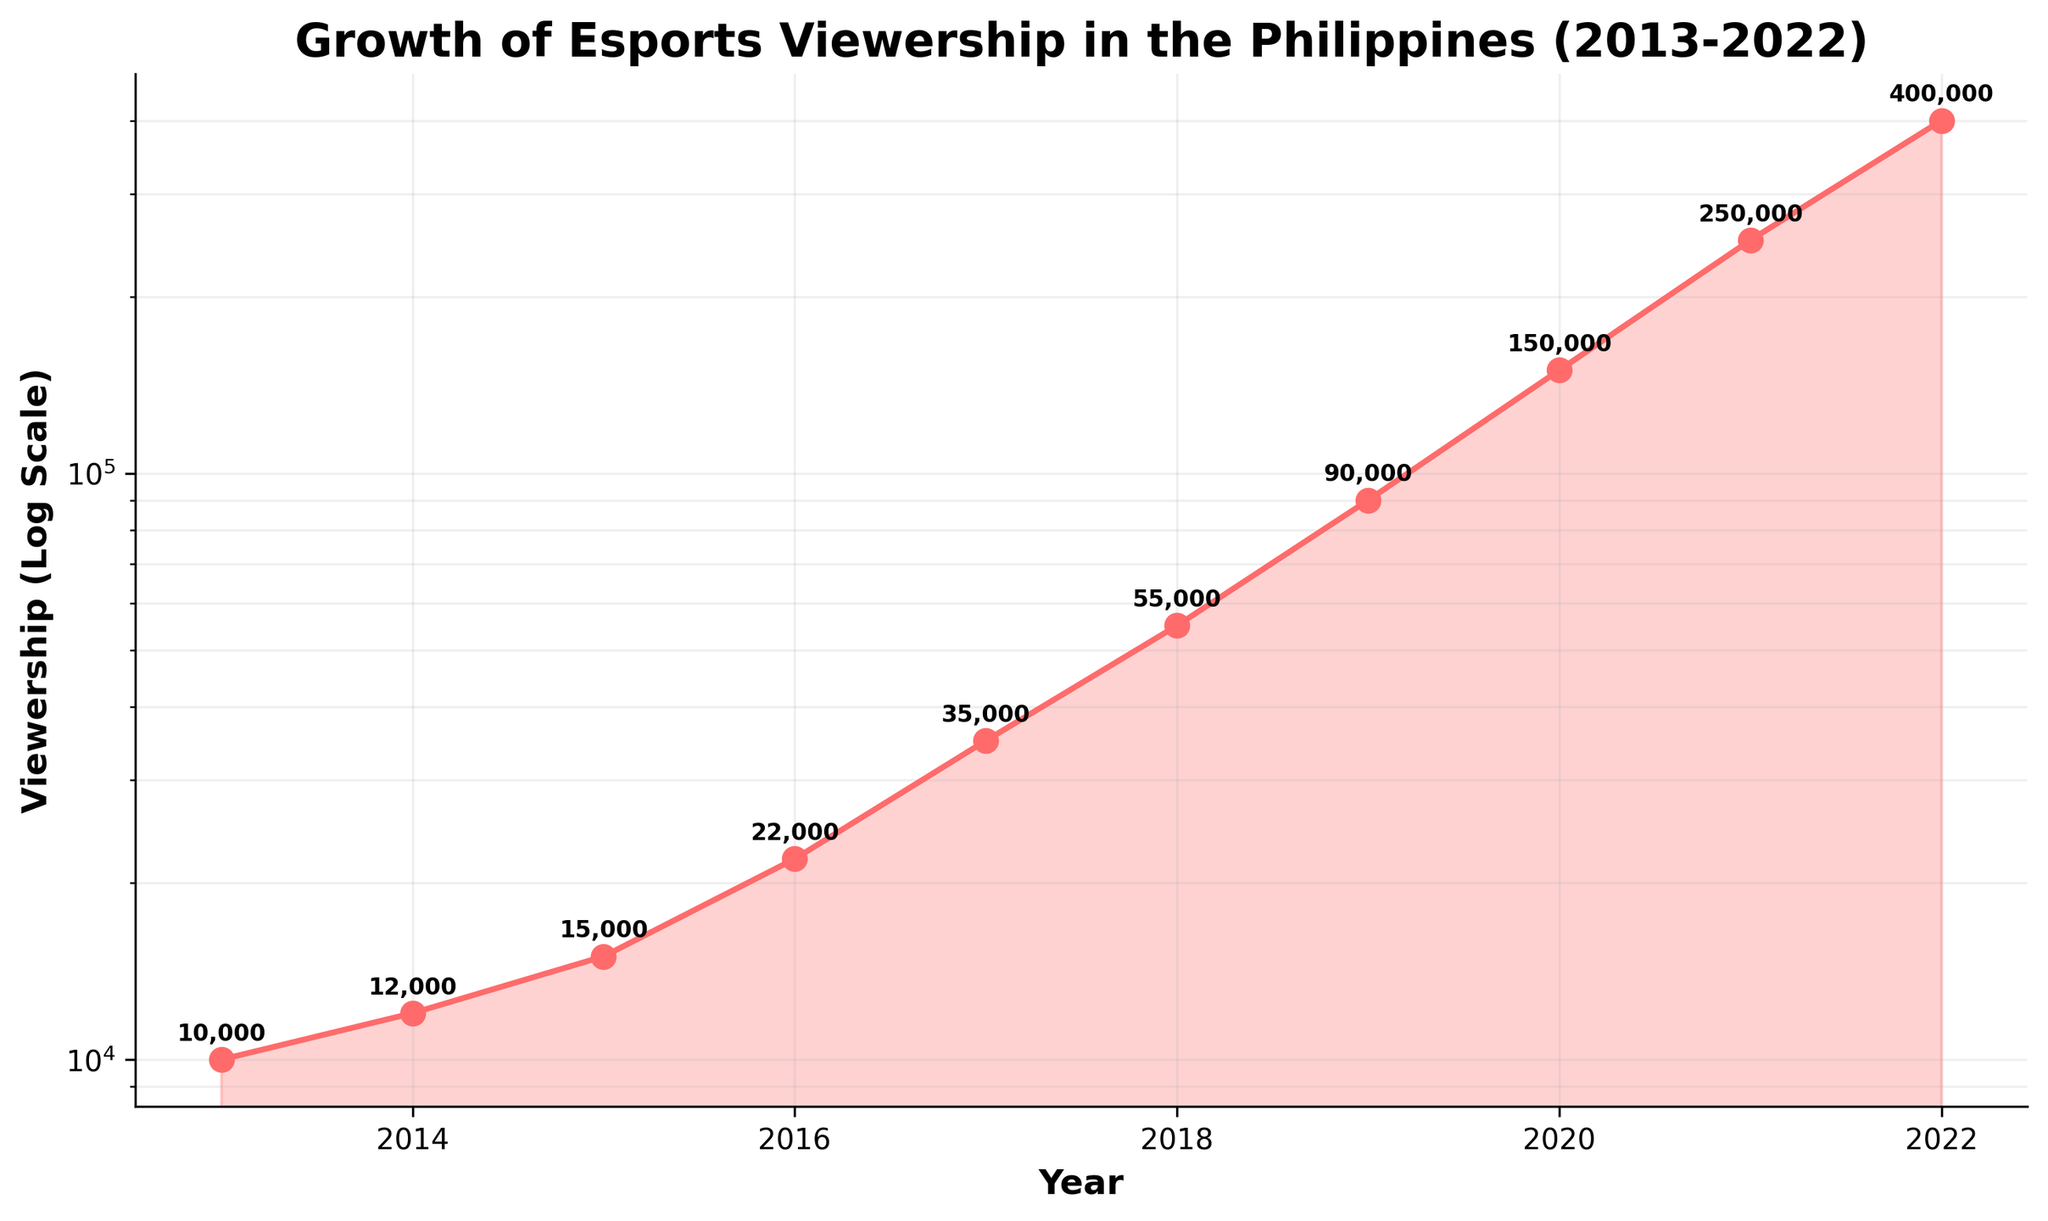What is the title of the plot? The title is usually at the top of the plot, and in this case, it reads "Growth of Esports Viewership in the Philippines (2013-2022)"
Answer: Growth of Esports Viewership in the Philippines (2013-2022) How many data points are plotted? By counting the markers (points) on the plot or the annotations for the viewership numbers, you can see there are 10 data points, which correspond to each year from 2013 to 2022
Answer: 10 What color is used to represent the viewership data? The color used for the viewership data is a shade of red, visible in both the line and the filled area under the line
Answer: Red What axis label is used for the x-axis? The label for the x-axis can be found directly below the x-axis itself, which reads "Year"
Answer: Year What is the value of viewership in 2020? The annotation above the data point for the year 2020 shows the viewership value, which is marked as 150,000
Answer: 150,000 Which year has the highest viewership and what is the value? By identifying the data point with the highest y-value and checking its corresponding year from the x-axis, we see that 2022 has the highest viewership value of 400,000
Answer: 2022, 400,000 By what factor did the viewership increase from 2013 to 2022? To calculate the factor, divide the viewership in 2022 (400,000) by the viewership in 2013 (10,000). 400,000 / 10,000 = 40, so the viewership increased by a factor of 40
Answer: 40 What is the average annual growth rate of viewership over the entire period? First, calculate the total growth by subtracting the initial viewership (10,000 in 2013) from the final viewership (400,000 in 2022). This gives 400,000 - 10,000 = 390,000. Since this growth occurred over 9 years (2022 - 2013), the average annual growth rate is 390,000 / 9 ≈ 43,333.33
Answer: 43,333.33 What is the largest single-year increase in viewership? Between which years did it occur? By comparing the differences in viewership values year-over-year, the largest increase is from 2019 (90,000) to 2020 (150,000), an increase of 60,000
Answer: 60,000, 2019 to 2020 What is the observation about the trend of viewership data on the log scale? On a log scale, exponential growth appears as a straight line. The viewership data shows an accelerating upward trend, indicating that the esports viewership in the Philippines grew exponentially over the period
Answer: Exponential growth 